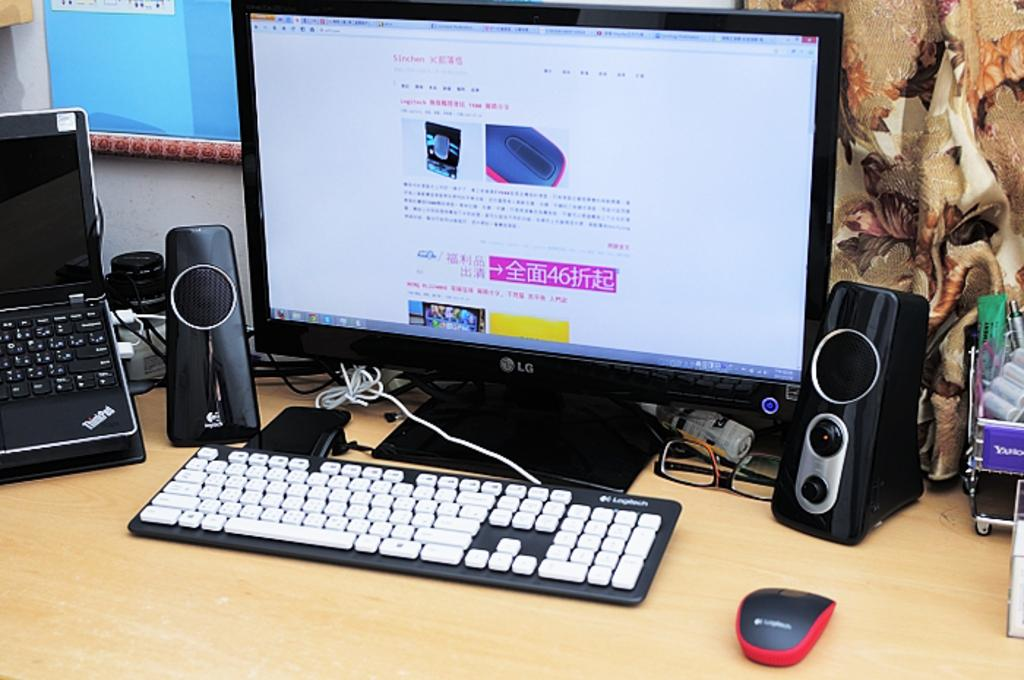<image>
Summarize the visual content of the image. Computer from LG with keyboard, speaker, and mouse 